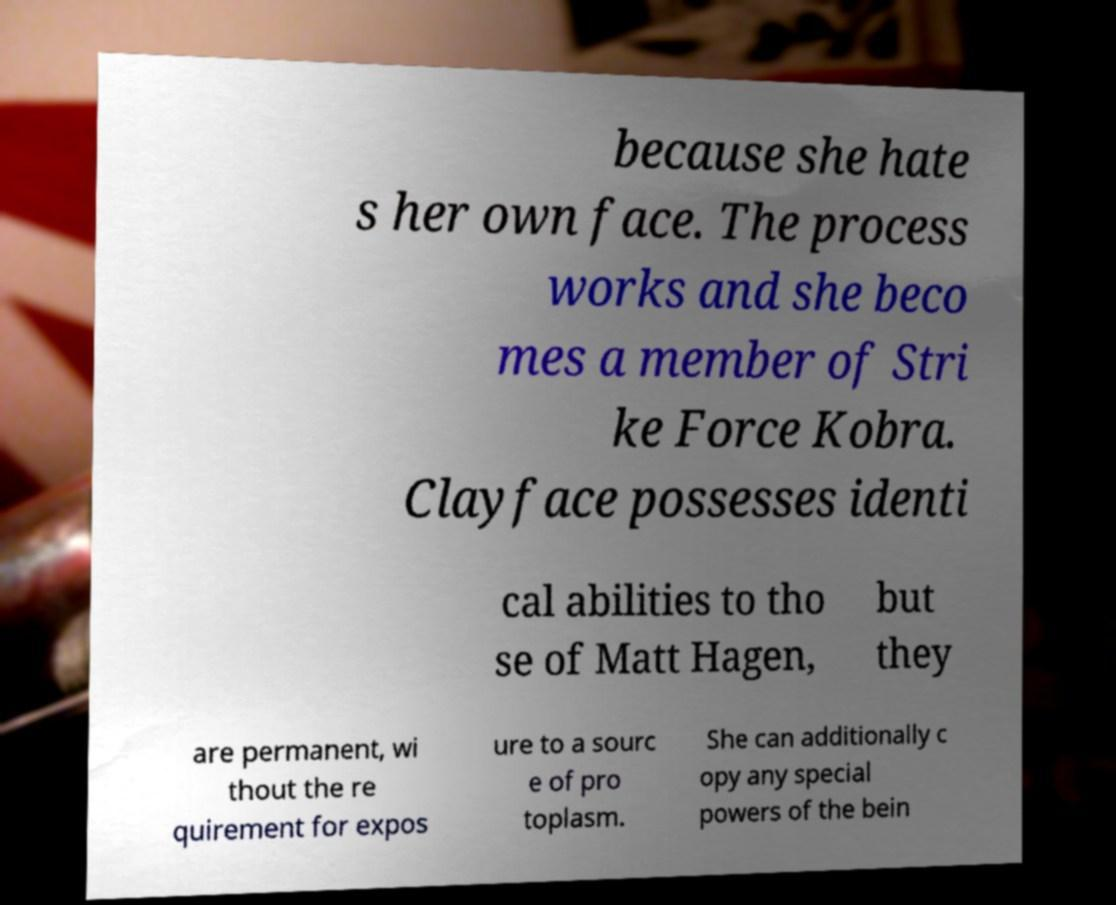There's text embedded in this image that I need extracted. Can you transcribe it verbatim? because she hate s her own face. The process works and she beco mes a member of Stri ke Force Kobra. Clayface possesses identi cal abilities to tho se of Matt Hagen, but they are permanent, wi thout the re quirement for expos ure to a sourc e of pro toplasm. She can additionally c opy any special powers of the bein 